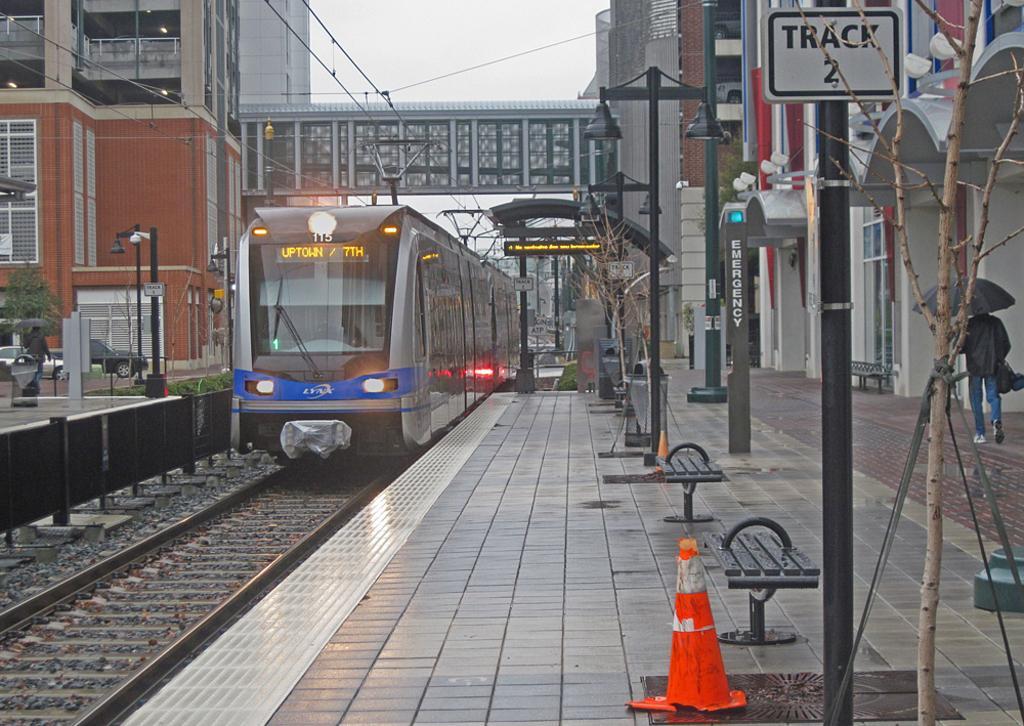Describe this image in one or two sentences. In this image I can see two people. I can see the vehicles. On the right side, I can see the benches. In the middle I can see a train on the railway track. In the background, I can see the buildings and the sky. 